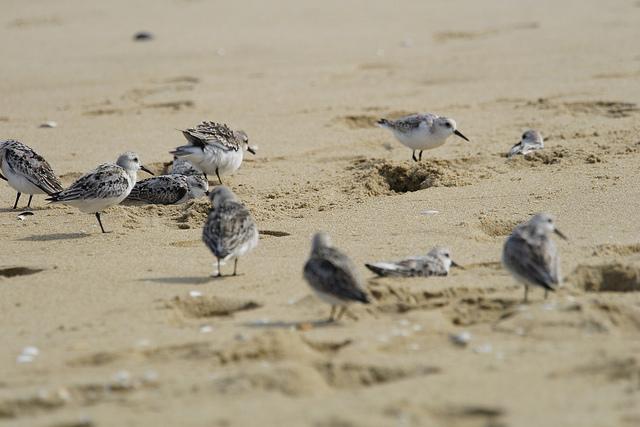Does this bird eat fish?
Give a very brief answer. Yes. What type of birds are next to the beach?
Be succinct. Seagull. Are the birds trying to build a nest?
Keep it brief. No. How many birds are there?
Concise answer only. 10. Would these birds be friendly to people?
Answer briefly. No. How many birds can you see?
Give a very brief answer. 10. Is this the beach??
Short answer required. Yes. 